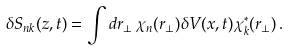Convert formula to latex. <formula><loc_0><loc_0><loc_500><loc_500>\delta S _ { n k } ( z , t ) = \int d { r } _ { \perp } \, \chi _ { n } ( { r } _ { \perp } ) \delta V ( { x } , t ) \chi _ { k } ^ { * } ( { r } _ { \perp } ) \, .</formula> 